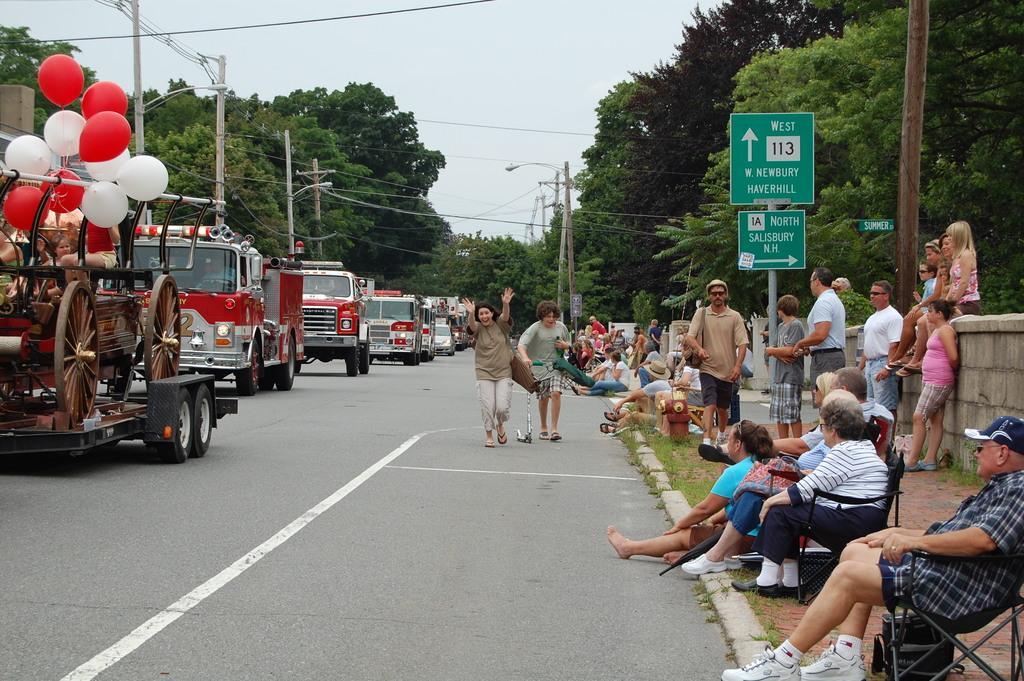In one or two sentences, can you explain what this image depicts? In this image there are group of persons standing and sitting and there is a board in the front with some text written on it. On the left side there are vehicles moving on the road. In the background there are trees, poles and there are persons standing on the ground. On the right side there is a wall. 